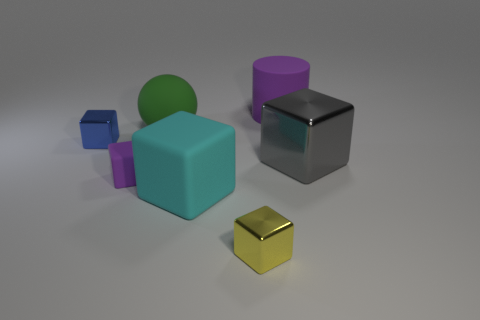Add 1 big purple objects. How many objects exist? 8 Subtract all yellow cubes. How many cubes are left? 4 Subtract all tiny matte blocks. How many blocks are left? 4 Subtract 2 cubes. How many cubes are left? 3 Subtract all blue blocks. Subtract all green cylinders. How many blocks are left? 4 Subtract all cylinders. How many objects are left? 6 Subtract 0 green blocks. How many objects are left? 7 Subtract all tiny red rubber cylinders. Subtract all blue metallic things. How many objects are left? 6 Add 7 green rubber balls. How many green rubber balls are left? 8 Add 3 blue rubber blocks. How many blue rubber blocks exist? 3 